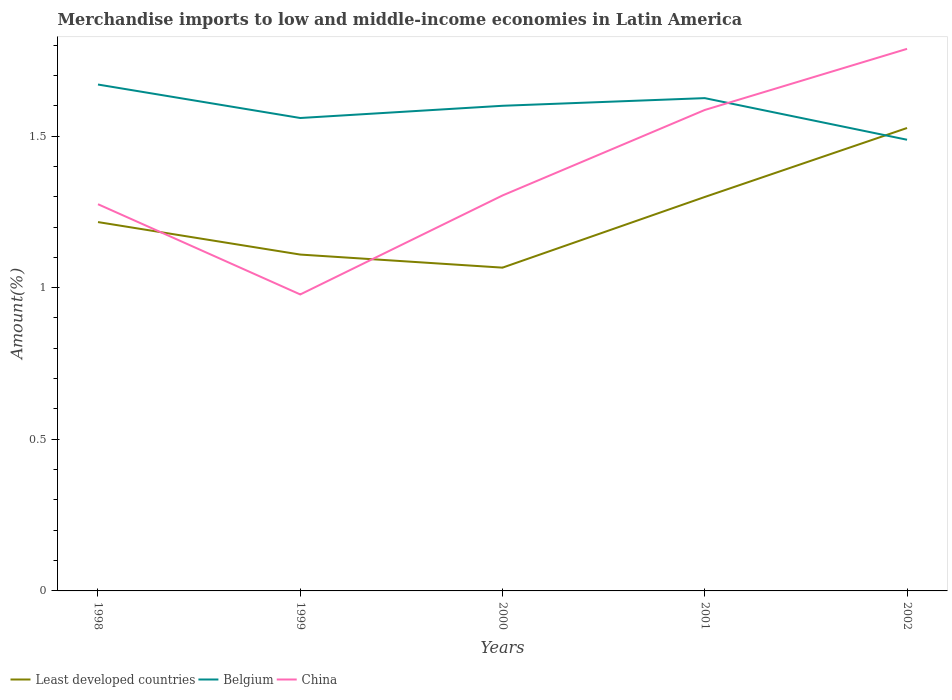Is the number of lines equal to the number of legend labels?
Provide a succinct answer. Yes. Across all years, what is the maximum percentage of amount earned from merchandise imports in Least developed countries?
Your answer should be very brief. 1.07. What is the total percentage of amount earned from merchandise imports in Belgium in the graph?
Give a very brief answer. 0.11. What is the difference between the highest and the second highest percentage of amount earned from merchandise imports in China?
Keep it short and to the point. 0.81. Is the percentage of amount earned from merchandise imports in China strictly greater than the percentage of amount earned from merchandise imports in Least developed countries over the years?
Provide a short and direct response. No. What is the difference between two consecutive major ticks on the Y-axis?
Ensure brevity in your answer.  0.5. Are the values on the major ticks of Y-axis written in scientific E-notation?
Your answer should be compact. No. Does the graph contain any zero values?
Provide a short and direct response. No. Does the graph contain grids?
Your answer should be compact. No. How many legend labels are there?
Keep it short and to the point. 3. What is the title of the graph?
Offer a very short reply. Merchandise imports to low and middle-income economies in Latin America. Does "Ecuador" appear as one of the legend labels in the graph?
Your answer should be very brief. No. What is the label or title of the X-axis?
Provide a succinct answer. Years. What is the label or title of the Y-axis?
Offer a terse response. Amount(%). What is the Amount(%) in Least developed countries in 1998?
Offer a terse response. 1.22. What is the Amount(%) in Belgium in 1998?
Ensure brevity in your answer.  1.67. What is the Amount(%) in China in 1998?
Your answer should be very brief. 1.28. What is the Amount(%) of Least developed countries in 1999?
Your response must be concise. 1.11. What is the Amount(%) in Belgium in 1999?
Make the answer very short. 1.56. What is the Amount(%) in China in 1999?
Your answer should be compact. 0.98. What is the Amount(%) of Least developed countries in 2000?
Provide a succinct answer. 1.07. What is the Amount(%) of Belgium in 2000?
Your response must be concise. 1.6. What is the Amount(%) of China in 2000?
Keep it short and to the point. 1.3. What is the Amount(%) of Least developed countries in 2001?
Offer a very short reply. 1.3. What is the Amount(%) of Belgium in 2001?
Make the answer very short. 1.63. What is the Amount(%) of China in 2001?
Give a very brief answer. 1.59. What is the Amount(%) of Least developed countries in 2002?
Your response must be concise. 1.53. What is the Amount(%) in Belgium in 2002?
Give a very brief answer. 1.49. What is the Amount(%) of China in 2002?
Your answer should be compact. 1.79. Across all years, what is the maximum Amount(%) in Least developed countries?
Provide a succinct answer. 1.53. Across all years, what is the maximum Amount(%) in Belgium?
Your response must be concise. 1.67. Across all years, what is the maximum Amount(%) of China?
Give a very brief answer. 1.79. Across all years, what is the minimum Amount(%) of Least developed countries?
Offer a terse response. 1.07. Across all years, what is the minimum Amount(%) in Belgium?
Your answer should be compact. 1.49. Across all years, what is the minimum Amount(%) in China?
Offer a terse response. 0.98. What is the total Amount(%) in Least developed countries in the graph?
Keep it short and to the point. 6.22. What is the total Amount(%) of Belgium in the graph?
Offer a terse response. 7.94. What is the total Amount(%) of China in the graph?
Your answer should be very brief. 6.93. What is the difference between the Amount(%) in Least developed countries in 1998 and that in 1999?
Make the answer very short. 0.11. What is the difference between the Amount(%) in Belgium in 1998 and that in 1999?
Offer a terse response. 0.11. What is the difference between the Amount(%) in China in 1998 and that in 1999?
Offer a very short reply. 0.3. What is the difference between the Amount(%) of Least developed countries in 1998 and that in 2000?
Give a very brief answer. 0.15. What is the difference between the Amount(%) in Belgium in 1998 and that in 2000?
Offer a terse response. 0.07. What is the difference between the Amount(%) in China in 1998 and that in 2000?
Offer a very short reply. -0.03. What is the difference between the Amount(%) of Least developed countries in 1998 and that in 2001?
Your answer should be compact. -0.08. What is the difference between the Amount(%) of Belgium in 1998 and that in 2001?
Ensure brevity in your answer.  0.04. What is the difference between the Amount(%) in China in 1998 and that in 2001?
Provide a succinct answer. -0.31. What is the difference between the Amount(%) in Least developed countries in 1998 and that in 2002?
Offer a terse response. -0.31. What is the difference between the Amount(%) of Belgium in 1998 and that in 2002?
Your answer should be very brief. 0.18. What is the difference between the Amount(%) of China in 1998 and that in 2002?
Offer a very short reply. -0.51. What is the difference between the Amount(%) of Least developed countries in 1999 and that in 2000?
Provide a short and direct response. 0.04. What is the difference between the Amount(%) of Belgium in 1999 and that in 2000?
Keep it short and to the point. -0.04. What is the difference between the Amount(%) of China in 1999 and that in 2000?
Make the answer very short. -0.33. What is the difference between the Amount(%) of Least developed countries in 1999 and that in 2001?
Offer a terse response. -0.19. What is the difference between the Amount(%) in Belgium in 1999 and that in 2001?
Provide a short and direct response. -0.07. What is the difference between the Amount(%) of China in 1999 and that in 2001?
Keep it short and to the point. -0.61. What is the difference between the Amount(%) of Least developed countries in 1999 and that in 2002?
Offer a very short reply. -0.42. What is the difference between the Amount(%) of Belgium in 1999 and that in 2002?
Offer a very short reply. 0.07. What is the difference between the Amount(%) in China in 1999 and that in 2002?
Make the answer very short. -0.81. What is the difference between the Amount(%) in Least developed countries in 2000 and that in 2001?
Provide a short and direct response. -0.23. What is the difference between the Amount(%) in Belgium in 2000 and that in 2001?
Offer a very short reply. -0.03. What is the difference between the Amount(%) in China in 2000 and that in 2001?
Your response must be concise. -0.28. What is the difference between the Amount(%) in Least developed countries in 2000 and that in 2002?
Offer a terse response. -0.46. What is the difference between the Amount(%) of Belgium in 2000 and that in 2002?
Ensure brevity in your answer.  0.11. What is the difference between the Amount(%) of China in 2000 and that in 2002?
Your response must be concise. -0.48. What is the difference between the Amount(%) of Least developed countries in 2001 and that in 2002?
Ensure brevity in your answer.  -0.23. What is the difference between the Amount(%) of Belgium in 2001 and that in 2002?
Ensure brevity in your answer.  0.14. What is the difference between the Amount(%) in China in 2001 and that in 2002?
Your answer should be compact. -0.2. What is the difference between the Amount(%) of Least developed countries in 1998 and the Amount(%) of Belgium in 1999?
Your answer should be very brief. -0.34. What is the difference between the Amount(%) of Least developed countries in 1998 and the Amount(%) of China in 1999?
Offer a terse response. 0.24. What is the difference between the Amount(%) in Belgium in 1998 and the Amount(%) in China in 1999?
Ensure brevity in your answer.  0.69. What is the difference between the Amount(%) of Least developed countries in 1998 and the Amount(%) of Belgium in 2000?
Offer a very short reply. -0.38. What is the difference between the Amount(%) in Least developed countries in 1998 and the Amount(%) in China in 2000?
Ensure brevity in your answer.  -0.09. What is the difference between the Amount(%) of Belgium in 1998 and the Amount(%) of China in 2000?
Provide a succinct answer. 0.37. What is the difference between the Amount(%) of Least developed countries in 1998 and the Amount(%) of Belgium in 2001?
Offer a very short reply. -0.41. What is the difference between the Amount(%) in Least developed countries in 1998 and the Amount(%) in China in 2001?
Your response must be concise. -0.37. What is the difference between the Amount(%) of Belgium in 1998 and the Amount(%) of China in 2001?
Your answer should be very brief. 0.08. What is the difference between the Amount(%) of Least developed countries in 1998 and the Amount(%) of Belgium in 2002?
Your answer should be very brief. -0.27. What is the difference between the Amount(%) in Least developed countries in 1998 and the Amount(%) in China in 2002?
Make the answer very short. -0.57. What is the difference between the Amount(%) of Belgium in 1998 and the Amount(%) of China in 2002?
Give a very brief answer. -0.12. What is the difference between the Amount(%) in Least developed countries in 1999 and the Amount(%) in Belgium in 2000?
Make the answer very short. -0.49. What is the difference between the Amount(%) of Least developed countries in 1999 and the Amount(%) of China in 2000?
Ensure brevity in your answer.  -0.19. What is the difference between the Amount(%) of Belgium in 1999 and the Amount(%) of China in 2000?
Provide a short and direct response. 0.26. What is the difference between the Amount(%) in Least developed countries in 1999 and the Amount(%) in Belgium in 2001?
Provide a succinct answer. -0.52. What is the difference between the Amount(%) in Least developed countries in 1999 and the Amount(%) in China in 2001?
Your answer should be compact. -0.48. What is the difference between the Amount(%) of Belgium in 1999 and the Amount(%) of China in 2001?
Provide a succinct answer. -0.03. What is the difference between the Amount(%) of Least developed countries in 1999 and the Amount(%) of Belgium in 2002?
Offer a very short reply. -0.38. What is the difference between the Amount(%) of Least developed countries in 1999 and the Amount(%) of China in 2002?
Make the answer very short. -0.68. What is the difference between the Amount(%) of Belgium in 1999 and the Amount(%) of China in 2002?
Your answer should be very brief. -0.23. What is the difference between the Amount(%) in Least developed countries in 2000 and the Amount(%) in Belgium in 2001?
Ensure brevity in your answer.  -0.56. What is the difference between the Amount(%) in Least developed countries in 2000 and the Amount(%) in China in 2001?
Provide a short and direct response. -0.52. What is the difference between the Amount(%) in Belgium in 2000 and the Amount(%) in China in 2001?
Your answer should be compact. 0.01. What is the difference between the Amount(%) in Least developed countries in 2000 and the Amount(%) in Belgium in 2002?
Keep it short and to the point. -0.42. What is the difference between the Amount(%) of Least developed countries in 2000 and the Amount(%) of China in 2002?
Give a very brief answer. -0.72. What is the difference between the Amount(%) of Belgium in 2000 and the Amount(%) of China in 2002?
Your answer should be very brief. -0.19. What is the difference between the Amount(%) in Least developed countries in 2001 and the Amount(%) in Belgium in 2002?
Your response must be concise. -0.19. What is the difference between the Amount(%) of Least developed countries in 2001 and the Amount(%) of China in 2002?
Offer a very short reply. -0.49. What is the difference between the Amount(%) in Belgium in 2001 and the Amount(%) in China in 2002?
Keep it short and to the point. -0.16. What is the average Amount(%) in Least developed countries per year?
Your response must be concise. 1.24. What is the average Amount(%) in Belgium per year?
Your answer should be compact. 1.59. What is the average Amount(%) in China per year?
Provide a short and direct response. 1.39. In the year 1998, what is the difference between the Amount(%) in Least developed countries and Amount(%) in Belgium?
Keep it short and to the point. -0.45. In the year 1998, what is the difference between the Amount(%) in Least developed countries and Amount(%) in China?
Ensure brevity in your answer.  -0.06. In the year 1998, what is the difference between the Amount(%) in Belgium and Amount(%) in China?
Ensure brevity in your answer.  0.39. In the year 1999, what is the difference between the Amount(%) of Least developed countries and Amount(%) of Belgium?
Ensure brevity in your answer.  -0.45. In the year 1999, what is the difference between the Amount(%) in Least developed countries and Amount(%) in China?
Offer a terse response. 0.13. In the year 1999, what is the difference between the Amount(%) of Belgium and Amount(%) of China?
Offer a very short reply. 0.58. In the year 2000, what is the difference between the Amount(%) of Least developed countries and Amount(%) of Belgium?
Give a very brief answer. -0.53. In the year 2000, what is the difference between the Amount(%) of Least developed countries and Amount(%) of China?
Provide a succinct answer. -0.24. In the year 2000, what is the difference between the Amount(%) of Belgium and Amount(%) of China?
Make the answer very short. 0.3. In the year 2001, what is the difference between the Amount(%) of Least developed countries and Amount(%) of Belgium?
Your answer should be compact. -0.33. In the year 2001, what is the difference between the Amount(%) in Least developed countries and Amount(%) in China?
Provide a short and direct response. -0.29. In the year 2001, what is the difference between the Amount(%) in Belgium and Amount(%) in China?
Your answer should be very brief. 0.04. In the year 2002, what is the difference between the Amount(%) of Least developed countries and Amount(%) of Belgium?
Give a very brief answer. 0.04. In the year 2002, what is the difference between the Amount(%) of Least developed countries and Amount(%) of China?
Your answer should be very brief. -0.26. In the year 2002, what is the difference between the Amount(%) of Belgium and Amount(%) of China?
Make the answer very short. -0.3. What is the ratio of the Amount(%) in Least developed countries in 1998 to that in 1999?
Keep it short and to the point. 1.1. What is the ratio of the Amount(%) in Belgium in 1998 to that in 1999?
Offer a terse response. 1.07. What is the ratio of the Amount(%) of China in 1998 to that in 1999?
Your answer should be compact. 1.3. What is the ratio of the Amount(%) of Least developed countries in 1998 to that in 2000?
Your answer should be compact. 1.14. What is the ratio of the Amount(%) of Belgium in 1998 to that in 2000?
Provide a short and direct response. 1.04. What is the ratio of the Amount(%) in China in 1998 to that in 2000?
Your response must be concise. 0.98. What is the ratio of the Amount(%) in Least developed countries in 1998 to that in 2001?
Keep it short and to the point. 0.94. What is the ratio of the Amount(%) of Belgium in 1998 to that in 2001?
Make the answer very short. 1.03. What is the ratio of the Amount(%) in China in 1998 to that in 2001?
Keep it short and to the point. 0.8. What is the ratio of the Amount(%) in Least developed countries in 1998 to that in 2002?
Keep it short and to the point. 0.8. What is the ratio of the Amount(%) in Belgium in 1998 to that in 2002?
Provide a succinct answer. 1.12. What is the ratio of the Amount(%) in China in 1998 to that in 2002?
Keep it short and to the point. 0.71. What is the ratio of the Amount(%) of Least developed countries in 1999 to that in 2000?
Provide a succinct answer. 1.04. What is the ratio of the Amount(%) in Belgium in 1999 to that in 2000?
Your response must be concise. 0.97. What is the ratio of the Amount(%) in China in 1999 to that in 2000?
Offer a terse response. 0.75. What is the ratio of the Amount(%) in Least developed countries in 1999 to that in 2001?
Keep it short and to the point. 0.85. What is the ratio of the Amount(%) in Belgium in 1999 to that in 2001?
Provide a succinct answer. 0.96. What is the ratio of the Amount(%) in China in 1999 to that in 2001?
Offer a terse response. 0.62. What is the ratio of the Amount(%) of Least developed countries in 1999 to that in 2002?
Give a very brief answer. 0.73. What is the ratio of the Amount(%) of Belgium in 1999 to that in 2002?
Provide a short and direct response. 1.05. What is the ratio of the Amount(%) of China in 1999 to that in 2002?
Provide a succinct answer. 0.55. What is the ratio of the Amount(%) of Least developed countries in 2000 to that in 2001?
Provide a short and direct response. 0.82. What is the ratio of the Amount(%) in Belgium in 2000 to that in 2001?
Offer a terse response. 0.98. What is the ratio of the Amount(%) in China in 2000 to that in 2001?
Make the answer very short. 0.82. What is the ratio of the Amount(%) in Least developed countries in 2000 to that in 2002?
Make the answer very short. 0.7. What is the ratio of the Amount(%) of Belgium in 2000 to that in 2002?
Provide a succinct answer. 1.08. What is the ratio of the Amount(%) of China in 2000 to that in 2002?
Your answer should be very brief. 0.73. What is the ratio of the Amount(%) of Least developed countries in 2001 to that in 2002?
Offer a terse response. 0.85. What is the ratio of the Amount(%) in Belgium in 2001 to that in 2002?
Give a very brief answer. 1.09. What is the ratio of the Amount(%) of China in 2001 to that in 2002?
Provide a succinct answer. 0.89. What is the difference between the highest and the second highest Amount(%) in Least developed countries?
Keep it short and to the point. 0.23. What is the difference between the highest and the second highest Amount(%) of Belgium?
Offer a terse response. 0.04. What is the difference between the highest and the second highest Amount(%) in China?
Your answer should be compact. 0.2. What is the difference between the highest and the lowest Amount(%) in Least developed countries?
Give a very brief answer. 0.46. What is the difference between the highest and the lowest Amount(%) in Belgium?
Ensure brevity in your answer.  0.18. What is the difference between the highest and the lowest Amount(%) in China?
Offer a terse response. 0.81. 